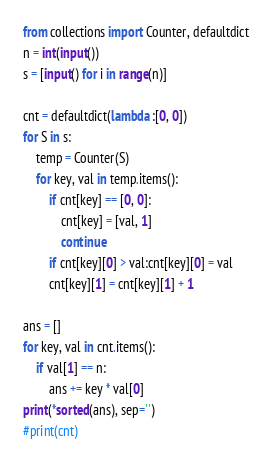Convert code to text. <code><loc_0><loc_0><loc_500><loc_500><_Python_>from collections import Counter, defaultdict
n = int(input())
s = [input() for i in range(n)]

cnt = defaultdict(lambda :[0, 0])
for S in s:
    temp = Counter(S)
    for key, val in temp.items():
        if cnt[key] == [0, 0]:
            cnt[key] = [val, 1]
            continue
        if cnt[key][0] > val:cnt[key][0] = val
        cnt[key][1] = cnt[key][1] + 1

ans = []
for key, val in cnt.items():
    if val[1] == n:
        ans += key * val[0]
print(*sorted(ans), sep='')
#print(cnt)</code> 